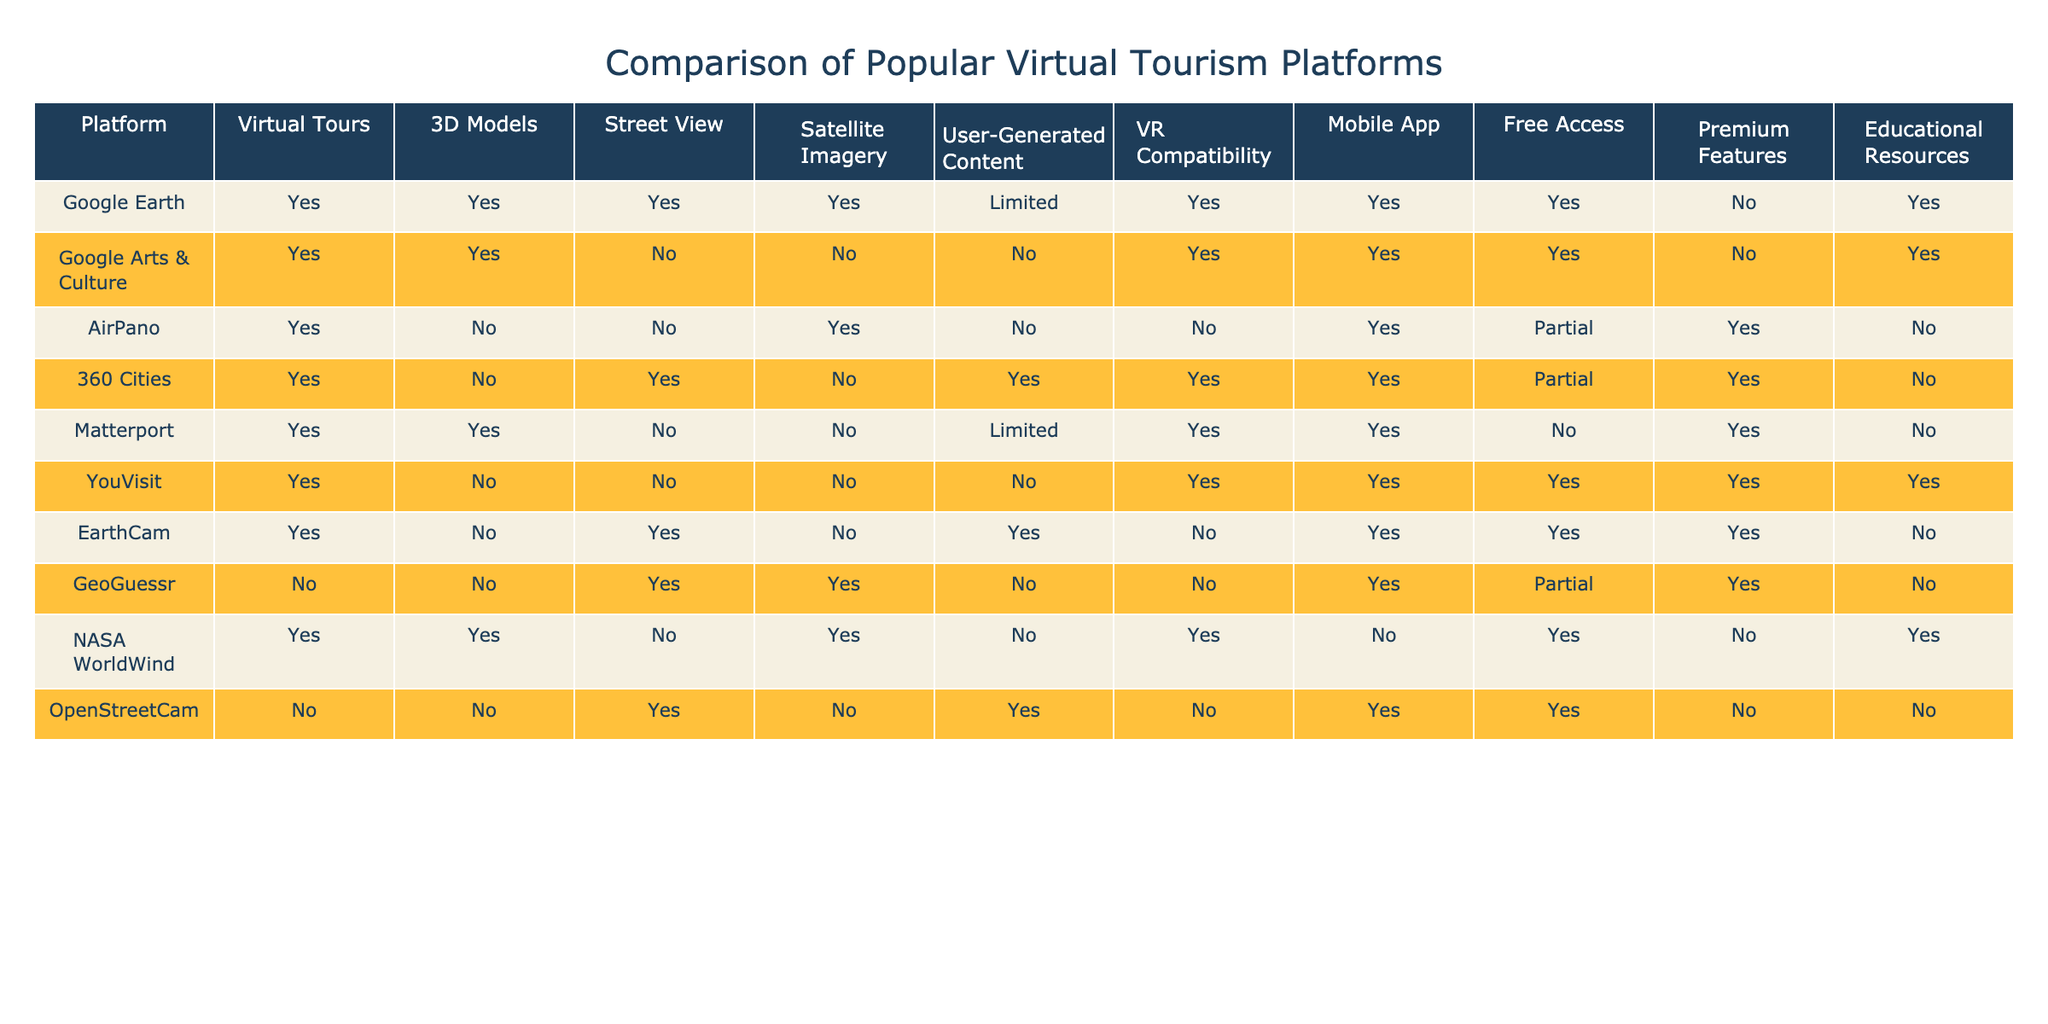What platforms offer street view capabilities? By examining the "Street View" column in the table, we can identify the platforms that have "Yes" listed under that feature. These platforms are Google Earth, 360 Cities, EarthCam, and GeoGuessr.
Answer: Google Earth, 360 Cities, EarthCam, GeoGuessr Which platform has the most educational resources? Looking at the "Educational Resources" column, we see that Google Earth, Google Arts & Culture, YouVisit, Matterport, NASA WorldWind, and AirPano all have "Yes" listed, indicating they offer educational resources. Out of these, Google Earth, Google Arts & Culture, and NASA WorldWind are notable for their extensive resources.
Answer: Google Earth, Google Arts & Culture, NASA WorldWind Is there any platform that provides both virtual tours and VR compatibility? We need to check both the "Virtual Tours" and "VR Compatibility" columns. Google Earth, Google Arts & Culture, Matterport, and YouVisit have "Yes" for both.
Answer: Google Earth, Google Arts & Culture, Matterport, YouVisit How many platforms offer mobile apps? To find this, we will count the instances of "Yes" in the "Mobile App" column. Upon inspection, we find that 6 platforms offer mobile apps: Google Earth, Google Arts & Culture, AirPano, 360 Cities, YouVisit, and EarthCam.
Answer: 6 Which platform has limited user-generated content and offers 3D models? We search for platforms in the table that show "Limited" under "User-Generated Content" and "Yes" under "3D Models." The platform that fits these criteria is Matterport.
Answer: Matterport What is the difference between the number of platforms that have free access and those with premium features? We first count the platforms with "Yes" in the "Free Access" column, which are Google Earth, Google Arts & Culture, YouVisit, EarthCam, and GeoGuessr (totaling 5). Then, we count those with "Yes" in the "Premium Features" column: AirPano, 360 Cities, Matterport, and YouVisit (totaling 4). The difference is 5 - 4 = 1.
Answer: 1 Are there any platforms with both satellite imagery and street view? We look at both columns simultaneously. The platforms that have "Yes" for both satellite imagery and street view are Google Earth and GeoGuessr.
Answer: Google Earth, GeoGuessr What percentage of platforms supports user-generated content? Counting the "Yes" responses in the "User-Generated Content" column, we find 4 platforms that offer it (Google Earth, 360 Cities, EarthCam, and OpenStreetCam). There are 10 platforms total, so the percentage is (4/10) * 100 = 40%.
Answer: 40% 